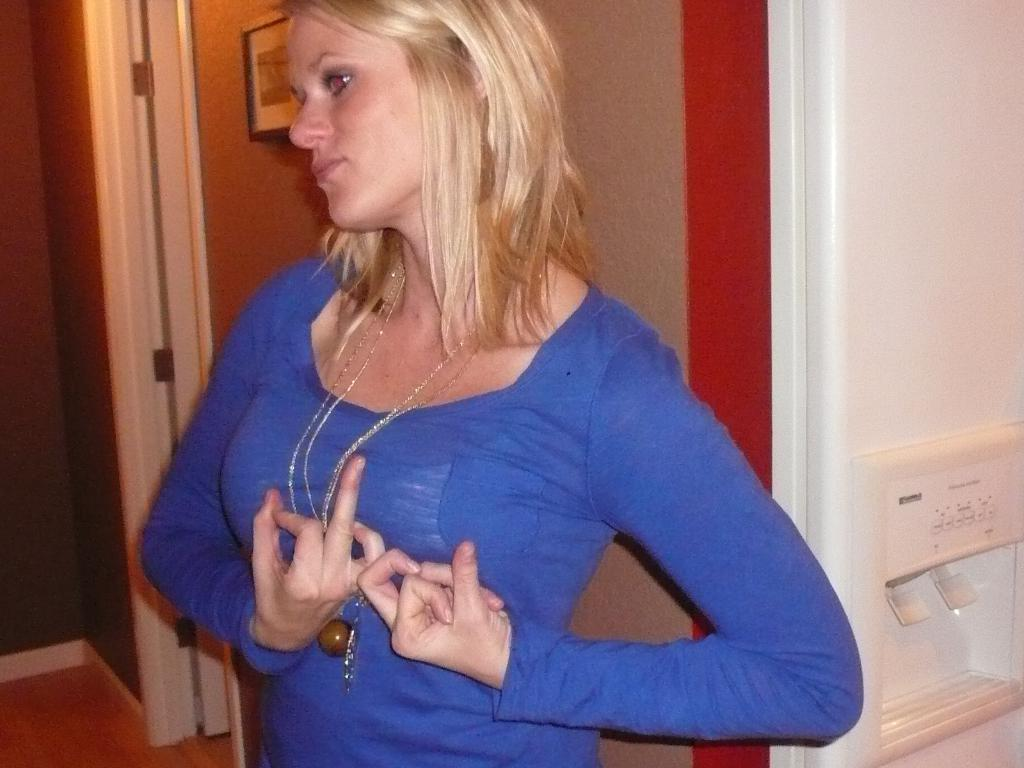Who is the main subject in the image? There is a woman in the image. What is the woman doing in the image? The woman is standing. What color are the clothes the woman is wearing? The woman is wearing blue clothes. What can be seen in the background of the image? There are walls visible in the background of the image, along with other unspecified elements. What type of drain can be seen in the middle of the image? There is no drain present in the image. 